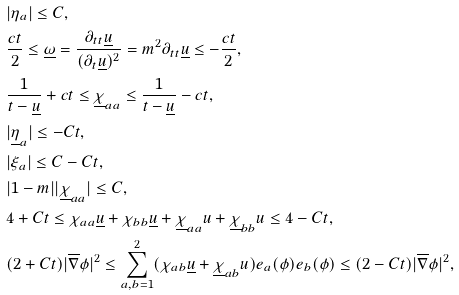Convert formula to latex. <formula><loc_0><loc_0><loc_500><loc_500>& | \eta _ { a } | \leq C , \\ & \frac { c t } { 2 } \leq \underline { \omega } = \frac { \partial _ { t t } \underline { u } } { ( \partial _ { t } \underline { u } ) ^ { 2 } } = m ^ { 2 } \partial _ { t t } \underline { u } \leq - \frac { c t } { 2 } , \\ & \frac { 1 } { t - \underline { u } } + c t \leq \underline { \chi } _ { a a } \leq \frac { 1 } { t - \underline { u } } - c t , \\ & | \underline { \eta } _ { a } | \leq - C t , \\ & | \xi _ { a } | \leq C - C t , \\ & | 1 - m | | \underline { \chi } _ { a a } | \leq C , \\ & 4 + C t \leq \chi _ { a a } \underline { u } + \chi _ { b b } \underline { u } + \underline { \chi } _ { a a } u + \underline { \chi } _ { b b } u \leq 4 - C t , \\ & ( 2 + C t ) | \overline { \nabla } \phi | ^ { 2 } \leq \sum _ { a , b = 1 } ^ { 2 } ( \chi _ { a b } \underline { u } + \underline { \chi } _ { a b } u ) e _ { a } ( \phi ) e _ { b } ( \phi ) \leq ( 2 - C t ) | \overline { \nabla } \phi | ^ { 2 } ,</formula> 